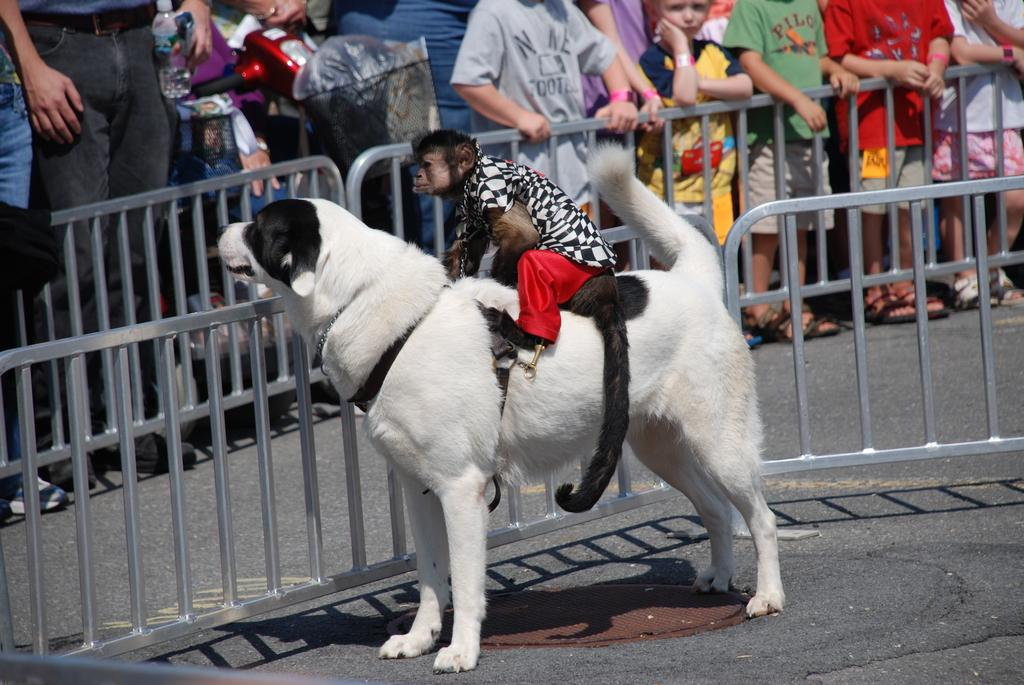How many groups of persons can be seen in the image? There are groups of persons in the image, but the exact number cannot be determined without more specific information. What are some of the persons holding in the image? Some persons are holding objects in the image, but the specific objects cannot be identified without more information. What type of fences are present in the image? The type of fences in the image cannot be determined without more specific information. What kind of animals are in the image? There are animals in the image, but the specific type of animals cannot be identified without more information. What is the purpose of the road in the image? The purpose of the road in the image cannot be determined without more specific information. What type of popcorn is being served in the image? There is no mention of popcorn in the image, so it cannot be determined if popcorn is being served. 